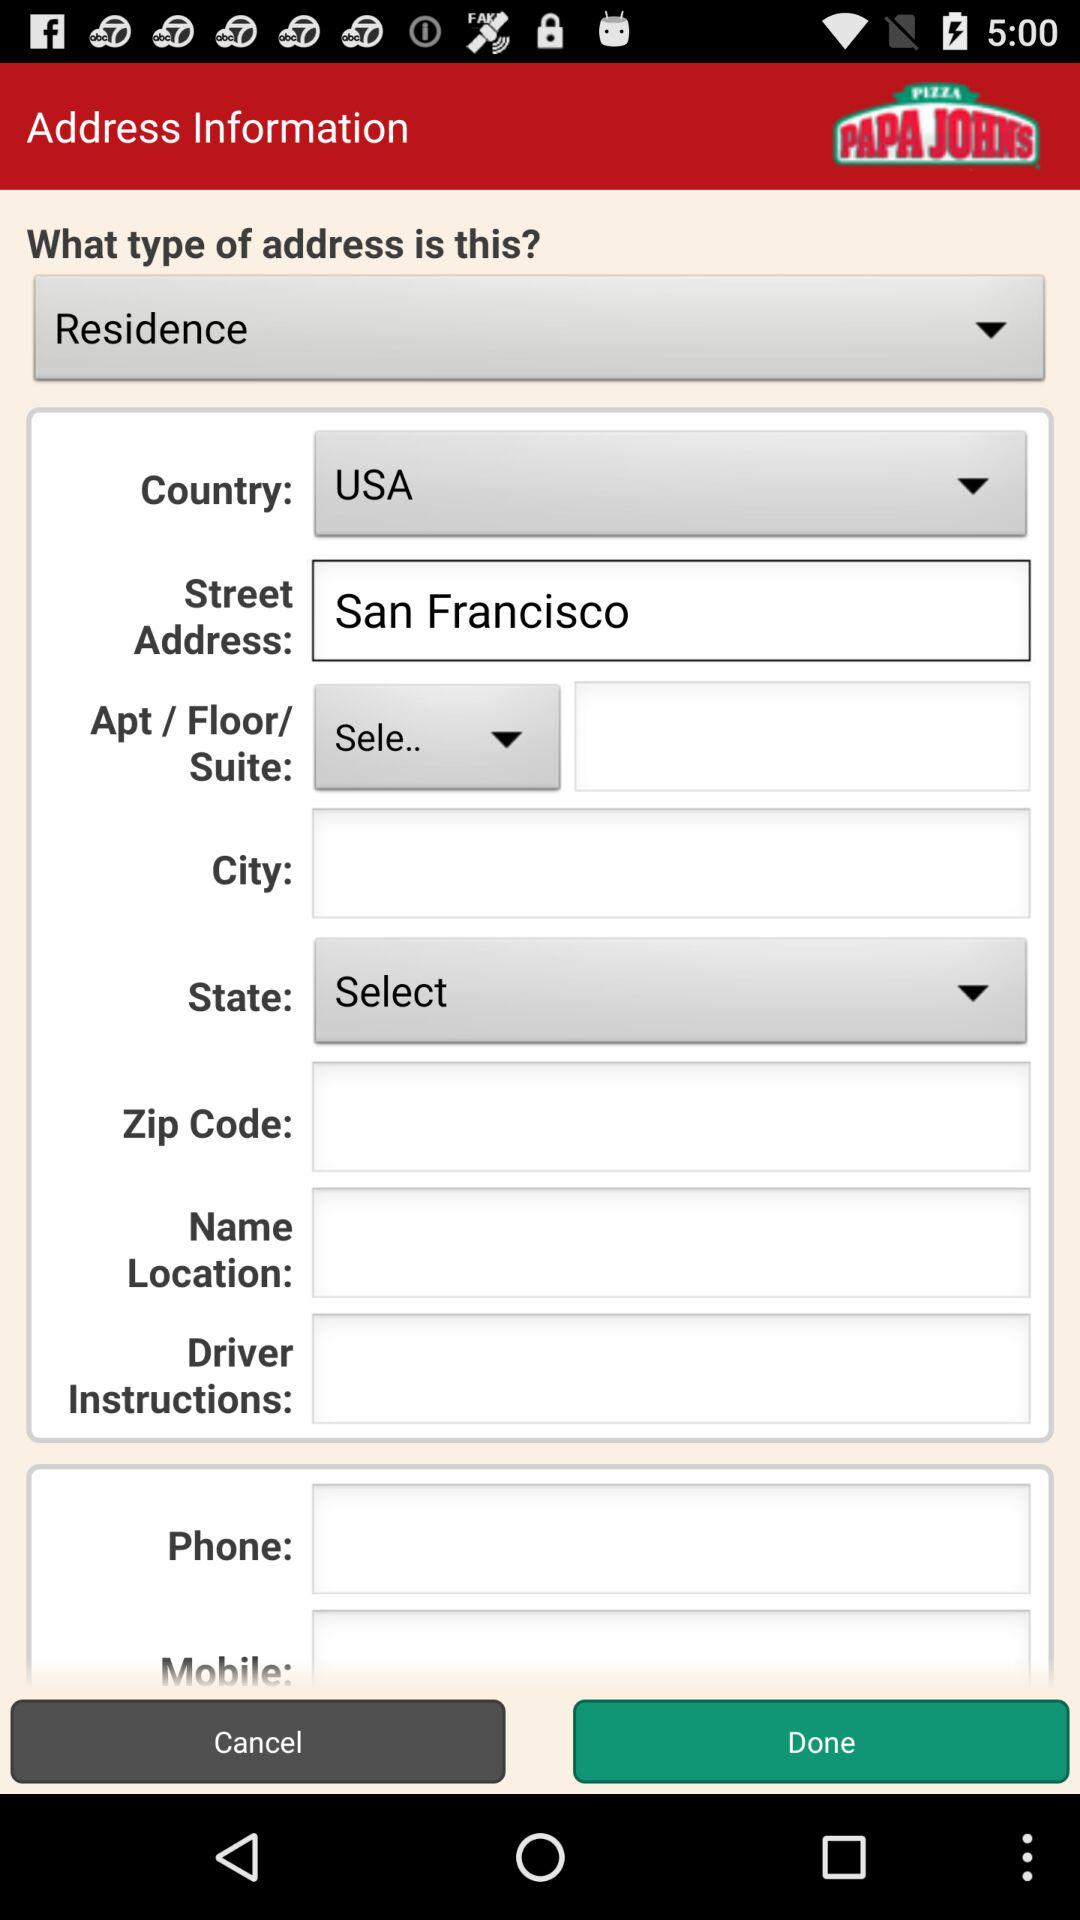What is the selected country? The selected country is the USA. 